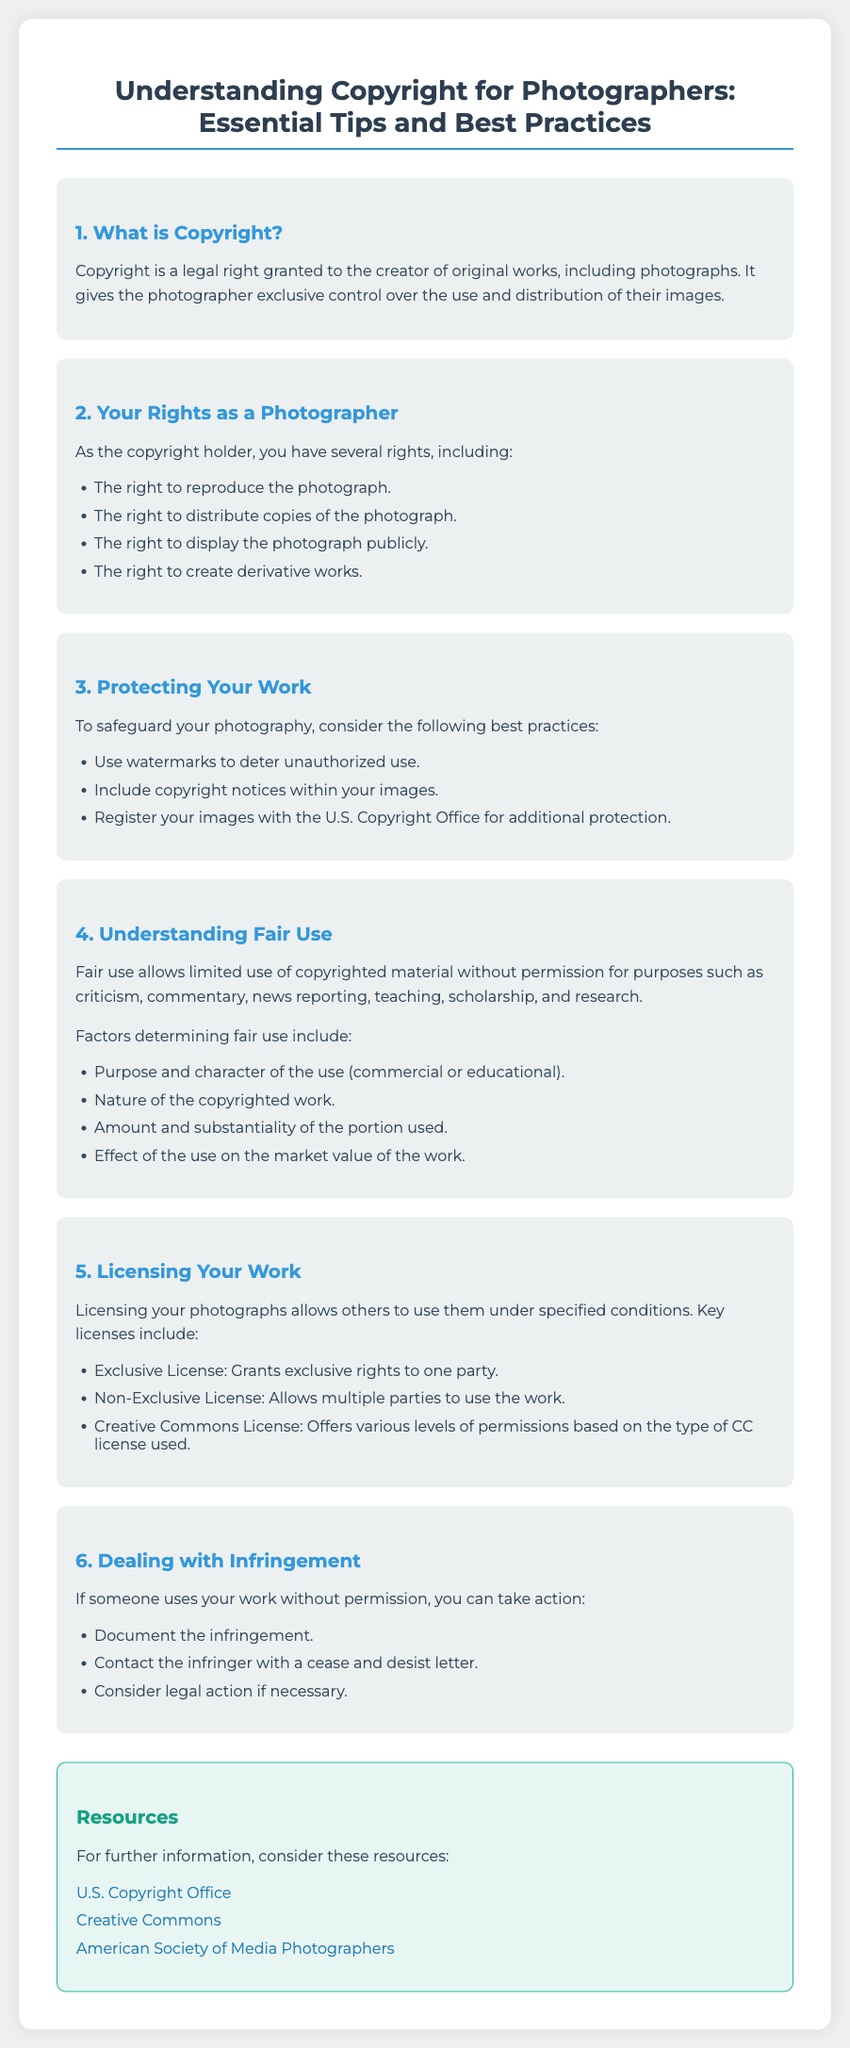What is copyright? Copyright is a legal right granted to the creator of original works, including photographs.
Answer: legal right What rights do photographers have? The section lists several rights photographers have as copyright holders.
Answer: reproduce, distribute, display, create derivative works What is a best practice to protect your work? The document mentions specific practices to safeguard photography.
Answer: Use watermarks What is fair use? Fair use allows limited use of copyrighted material without permission for specific purposes.
Answer: limited use What are the key types of licenses mentioned? The document specifies different types of licenses available for photographers.
Answer: Exclusive License, Non-Exclusive License, Creative Commons License What should you do if your work is infringed? The document outlines steps to take if someone uses your work without permission.
Answer: Document the infringement Which organization provides copyright information? The resources section lists various organizations that offer further information.
Answer: U.S. Copyright Office How many rights are listed under "Your Rights as a Photographer"? The number of rights listed in the document is relevant to understanding photographers' rights.
Answer: Four 